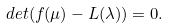<formula> <loc_0><loc_0><loc_500><loc_500>d e t ( f ( \mu ) - L ( \lambda ) ) = 0 .</formula> 